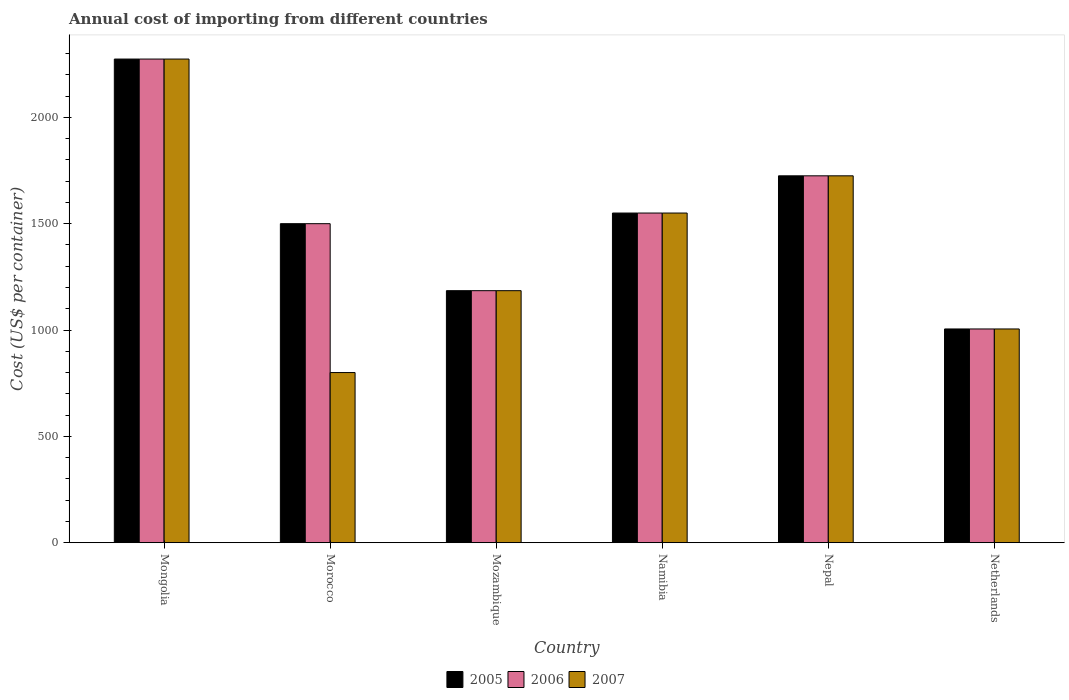How many groups of bars are there?
Offer a very short reply. 6. How many bars are there on the 4th tick from the left?
Offer a very short reply. 3. How many bars are there on the 1st tick from the right?
Your response must be concise. 3. What is the label of the 5th group of bars from the left?
Ensure brevity in your answer.  Nepal. In how many cases, is the number of bars for a given country not equal to the number of legend labels?
Provide a short and direct response. 0. What is the total annual cost of importing in 2007 in Netherlands?
Your answer should be very brief. 1005. Across all countries, what is the maximum total annual cost of importing in 2006?
Provide a succinct answer. 2274. Across all countries, what is the minimum total annual cost of importing in 2006?
Ensure brevity in your answer.  1005. In which country was the total annual cost of importing in 2005 maximum?
Your answer should be very brief. Mongolia. What is the total total annual cost of importing in 2007 in the graph?
Ensure brevity in your answer.  8539. What is the difference between the total annual cost of importing in 2005 in Morocco and that in Mozambique?
Your response must be concise. 315. What is the difference between the total annual cost of importing in 2007 in Morocco and the total annual cost of importing in 2006 in Namibia?
Provide a short and direct response. -750. What is the average total annual cost of importing in 2005 per country?
Provide a succinct answer. 1539.83. What is the ratio of the total annual cost of importing in 2006 in Nepal to that in Netherlands?
Provide a short and direct response. 1.72. Is the total annual cost of importing in 2005 in Mongolia less than that in Namibia?
Offer a very short reply. No. Is the difference between the total annual cost of importing in 2007 in Mongolia and Netherlands greater than the difference between the total annual cost of importing in 2006 in Mongolia and Netherlands?
Your answer should be compact. No. What is the difference between the highest and the second highest total annual cost of importing in 2007?
Offer a terse response. 549. What is the difference between the highest and the lowest total annual cost of importing in 2006?
Make the answer very short. 1269. In how many countries, is the total annual cost of importing in 2005 greater than the average total annual cost of importing in 2005 taken over all countries?
Provide a short and direct response. 3. What does the 1st bar from the left in Mozambique represents?
Your answer should be very brief. 2005. What does the 1st bar from the right in Morocco represents?
Provide a short and direct response. 2007. How many bars are there?
Ensure brevity in your answer.  18. Are all the bars in the graph horizontal?
Provide a short and direct response. No. Does the graph contain any zero values?
Provide a short and direct response. No. Does the graph contain grids?
Offer a very short reply. No. What is the title of the graph?
Make the answer very short. Annual cost of importing from different countries. What is the label or title of the X-axis?
Your response must be concise. Country. What is the label or title of the Y-axis?
Your answer should be very brief. Cost (US$ per container). What is the Cost (US$ per container) of 2005 in Mongolia?
Make the answer very short. 2274. What is the Cost (US$ per container) in 2006 in Mongolia?
Your answer should be compact. 2274. What is the Cost (US$ per container) in 2007 in Mongolia?
Keep it short and to the point. 2274. What is the Cost (US$ per container) of 2005 in Morocco?
Provide a short and direct response. 1500. What is the Cost (US$ per container) of 2006 in Morocco?
Your response must be concise. 1500. What is the Cost (US$ per container) in 2007 in Morocco?
Offer a terse response. 800. What is the Cost (US$ per container) of 2005 in Mozambique?
Offer a very short reply. 1185. What is the Cost (US$ per container) in 2006 in Mozambique?
Make the answer very short. 1185. What is the Cost (US$ per container) of 2007 in Mozambique?
Give a very brief answer. 1185. What is the Cost (US$ per container) in 2005 in Namibia?
Your answer should be very brief. 1550. What is the Cost (US$ per container) of 2006 in Namibia?
Provide a short and direct response. 1550. What is the Cost (US$ per container) in 2007 in Namibia?
Your answer should be compact. 1550. What is the Cost (US$ per container) in 2005 in Nepal?
Your response must be concise. 1725. What is the Cost (US$ per container) in 2006 in Nepal?
Provide a short and direct response. 1725. What is the Cost (US$ per container) of 2007 in Nepal?
Your answer should be compact. 1725. What is the Cost (US$ per container) in 2005 in Netherlands?
Keep it short and to the point. 1005. What is the Cost (US$ per container) in 2006 in Netherlands?
Your response must be concise. 1005. What is the Cost (US$ per container) of 2007 in Netherlands?
Give a very brief answer. 1005. Across all countries, what is the maximum Cost (US$ per container) in 2005?
Offer a terse response. 2274. Across all countries, what is the maximum Cost (US$ per container) of 2006?
Your answer should be very brief. 2274. Across all countries, what is the maximum Cost (US$ per container) of 2007?
Make the answer very short. 2274. Across all countries, what is the minimum Cost (US$ per container) in 2005?
Your answer should be compact. 1005. Across all countries, what is the minimum Cost (US$ per container) of 2006?
Make the answer very short. 1005. Across all countries, what is the minimum Cost (US$ per container) of 2007?
Ensure brevity in your answer.  800. What is the total Cost (US$ per container) in 2005 in the graph?
Your answer should be very brief. 9239. What is the total Cost (US$ per container) in 2006 in the graph?
Make the answer very short. 9239. What is the total Cost (US$ per container) of 2007 in the graph?
Your answer should be very brief. 8539. What is the difference between the Cost (US$ per container) in 2005 in Mongolia and that in Morocco?
Your response must be concise. 774. What is the difference between the Cost (US$ per container) of 2006 in Mongolia and that in Morocco?
Your answer should be very brief. 774. What is the difference between the Cost (US$ per container) of 2007 in Mongolia and that in Morocco?
Provide a succinct answer. 1474. What is the difference between the Cost (US$ per container) of 2005 in Mongolia and that in Mozambique?
Your response must be concise. 1089. What is the difference between the Cost (US$ per container) of 2006 in Mongolia and that in Mozambique?
Make the answer very short. 1089. What is the difference between the Cost (US$ per container) of 2007 in Mongolia and that in Mozambique?
Keep it short and to the point. 1089. What is the difference between the Cost (US$ per container) of 2005 in Mongolia and that in Namibia?
Provide a short and direct response. 724. What is the difference between the Cost (US$ per container) of 2006 in Mongolia and that in Namibia?
Give a very brief answer. 724. What is the difference between the Cost (US$ per container) in 2007 in Mongolia and that in Namibia?
Offer a terse response. 724. What is the difference between the Cost (US$ per container) of 2005 in Mongolia and that in Nepal?
Provide a succinct answer. 549. What is the difference between the Cost (US$ per container) in 2006 in Mongolia and that in Nepal?
Offer a very short reply. 549. What is the difference between the Cost (US$ per container) of 2007 in Mongolia and that in Nepal?
Provide a short and direct response. 549. What is the difference between the Cost (US$ per container) of 2005 in Mongolia and that in Netherlands?
Provide a succinct answer. 1269. What is the difference between the Cost (US$ per container) in 2006 in Mongolia and that in Netherlands?
Your response must be concise. 1269. What is the difference between the Cost (US$ per container) of 2007 in Mongolia and that in Netherlands?
Offer a very short reply. 1269. What is the difference between the Cost (US$ per container) of 2005 in Morocco and that in Mozambique?
Your answer should be very brief. 315. What is the difference between the Cost (US$ per container) of 2006 in Morocco and that in Mozambique?
Keep it short and to the point. 315. What is the difference between the Cost (US$ per container) of 2007 in Morocco and that in Mozambique?
Your answer should be compact. -385. What is the difference between the Cost (US$ per container) in 2007 in Morocco and that in Namibia?
Provide a short and direct response. -750. What is the difference between the Cost (US$ per container) in 2005 in Morocco and that in Nepal?
Make the answer very short. -225. What is the difference between the Cost (US$ per container) of 2006 in Morocco and that in Nepal?
Provide a succinct answer. -225. What is the difference between the Cost (US$ per container) in 2007 in Morocco and that in Nepal?
Provide a short and direct response. -925. What is the difference between the Cost (US$ per container) in 2005 in Morocco and that in Netherlands?
Your answer should be very brief. 495. What is the difference between the Cost (US$ per container) of 2006 in Morocco and that in Netherlands?
Your answer should be compact. 495. What is the difference between the Cost (US$ per container) in 2007 in Morocco and that in Netherlands?
Your response must be concise. -205. What is the difference between the Cost (US$ per container) of 2005 in Mozambique and that in Namibia?
Provide a short and direct response. -365. What is the difference between the Cost (US$ per container) of 2006 in Mozambique and that in Namibia?
Give a very brief answer. -365. What is the difference between the Cost (US$ per container) of 2007 in Mozambique and that in Namibia?
Offer a very short reply. -365. What is the difference between the Cost (US$ per container) of 2005 in Mozambique and that in Nepal?
Provide a short and direct response. -540. What is the difference between the Cost (US$ per container) in 2006 in Mozambique and that in Nepal?
Ensure brevity in your answer.  -540. What is the difference between the Cost (US$ per container) in 2007 in Mozambique and that in Nepal?
Offer a terse response. -540. What is the difference between the Cost (US$ per container) in 2005 in Mozambique and that in Netherlands?
Your response must be concise. 180. What is the difference between the Cost (US$ per container) of 2006 in Mozambique and that in Netherlands?
Give a very brief answer. 180. What is the difference between the Cost (US$ per container) in 2007 in Mozambique and that in Netherlands?
Provide a short and direct response. 180. What is the difference between the Cost (US$ per container) of 2005 in Namibia and that in Nepal?
Ensure brevity in your answer.  -175. What is the difference between the Cost (US$ per container) of 2006 in Namibia and that in Nepal?
Ensure brevity in your answer.  -175. What is the difference between the Cost (US$ per container) of 2007 in Namibia and that in Nepal?
Your response must be concise. -175. What is the difference between the Cost (US$ per container) in 2005 in Namibia and that in Netherlands?
Make the answer very short. 545. What is the difference between the Cost (US$ per container) of 2006 in Namibia and that in Netherlands?
Your answer should be compact. 545. What is the difference between the Cost (US$ per container) in 2007 in Namibia and that in Netherlands?
Make the answer very short. 545. What is the difference between the Cost (US$ per container) in 2005 in Nepal and that in Netherlands?
Keep it short and to the point. 720. What is the difference between the Cost (US$ per container) in 2006 in Nepal and that in Netherlands?
Provide a succinct answer. 720. What is the difference between the Cost (US$ per container) in 2007 in Nepal and that in Netherlands?
Your answer should be very brief. 720. What is the difference between the Cost (US$ per container) in 2005 in Mongolia and the Cost (US$ per container) in 2006 in Morocco?
Offer a very short reply. 774. What is the difference between the Cost (US$ per container) in 2005 in Mongolia and the Cost (US$ per container) in 2007 in Morocco?
Offer a terse response. 1474. What is the difference between the Cost (US$ per container) of 2006 in Mongolia and the Cost (US$ per container) of 2007 in Morocco?
Make the answer very short. 1474. What is the difference between the Cost (US$ per container) in 2005 in Mongolia and the Cost (US$ per container) in 2006 in Mozambique?
Provide a short and direct response. 1089. What is the difference between the Cost (US$ per container) of 2005 in Mongolia and the Cost (US$ per container) of 2007 in Mozambique?
Ensure brevity in your answer.  1089. What is the difference between the Cost (US$ per container) of 2006 in Mongolia and the Cost (US$ per container) of 2007 in Mozambique?
Make the answer very short. 1089. What is the difference between the Cost (US$ per container) in 2005 in Mongolia and the Cost (US$ per container) in 2006 in Namibia?
Offer a very short reply. 724. What is the difference between the Cost (US$ per container) in 2005 in Mongolia and the Cost (US$ per container) in 2007 in Namibia?
Your answer should be very brief. 724. What is the difference between the Cost (US$ per container) of 2006 in Mongolia and the Cost (US$ per container) of 2007 in Namibia?
Keep it short and to the point. 724. What is the difference between the Cost (US$ per container) of 2005 in Mongolia and the Cost (US$ per container) of 2006 in Nepal?
Your response must be concise. 549. What is the difference between the Cost (US$ per container) of 2005 in Mongolia and the Cost (US$ per container) of 2007 in Nepal?
Ensure brevity in your answer.  549. What is the difference between the Cost (US$ per container) of 2006 in Mongolia and the Cost (US$ per container) of 2007 in Nepal?
Your answer should be very brief. 549. What is the difference between the Cost (US$ per container) in 2005 in Mongolia and the Cost (US$ per container) in 2006 in Netherlands?
Make the answer very short. 1269. What is the difference between the Cost (US$ per container) in 2005 in Mongolia and the Cost (US$ per container) in 2007 in Netherlands?
Your answer should be very brief. 1269. What is the difference between the Cost (US$ per container) of 2006 in Mongolia and the Cost (US$ per container) of 2007 in Netherlands?
Your response must be concise. 1269. What is the difference between the Cost (US$ per container) of 2005 in Morocco and the Cost (US$ per container) of 2006 in Mozambique?
Your response must be concise. 315. What is the difference between the Cost (US$ per container) of 2005 in Morocco and the Cost (US$ per container) of 2007 in Mozambique?
Keep it short and to the point. 315. What is the difference between the Cost (US$ per container) of 2006 in Morocco and the Cost (US$ per container) of 2007 in Mozambique?
Offer a terse response. 315. What is the difference between the Cost (US$ per container) in 2005 in Morocco and the Cost (US$ per container) in 2006 in Namibia?
Keep it short and to the point. -50. What is the difference between the Cost (US$ per container) of 2005 in Morocco and the Cost (US$ per container) of 2006 in Nepal?
Keep it short and to the point. -225. What is the difference between the Cost (US$ per container) in 2005 in Morocco and the Cost (US$ per container) in 2007 in Nepal?
Give a very brief answer. -225. What is the difference between the Cost (US$ per container) in 2006 in Morocco and the Cost (US$ per container) in 2007 in Nepal?
Your answer should be very brief. -225. What is the difference between the Cost (US$ per container) of 2005 in Morocco and the Cost (US$ per container) of 2006 in Netherlands?
Provide a short and direct response. 495. What is the difference between the Cost (US$ per container) in 2005 in Morocco and the Cost (US$ per container) in 2007 in Netherlands?
Provide a short and direct response. 495. What is the difference between the Cost (US$ per container) in 2006 in Morocco and the Cost (US$ per container) in 2007 in Netherlands?
Offer a very short reply. 495. What is the difference between the Cost (US$ per container) in 2005 in Mozambique and the Cost (US$ per container) in 2006 in Namibia?
Make the answer very short. -365. What is the difference between the Cost (US$ per container) of 2005 in Mozambique and the Cost (US$ per container) of 2007 in Namibia?
Ensure brevity in your answer.  -365. What is the difference between the Cost (US$ per container) in 2006 in Mozambique and the Cost (US$ per container) in 2007 in Namibia?
Keep it short and to the point. -365. What is the difference between the Cost (US$ per container) in 2005 in Mozambique and the Cost (US$ per container) in 2006 in Nepal?
Provide a short and direct response. -540. What is the difference between the Cost (US$ per container) in 2005 in Mozambique and the Cost (US$ per container) in 2007 in Nepal?
Offer a terse response. -540. What is the difference between the Cost (US$ per container) in 2006 in Mozambique and the Cost (US$ per container) in 2007 in Nepal?
Your response must be concise. -540. What is the difference between the Cost (US$ per container) of 2005 in Mozambique and the Cost (US$ per container) of 2006 in Netherlands?
Ensure brevity in your answer.  180. What is the difference between the Cost (US$ per container) of 2005 in Mozambique and the Cost (US$ per container) of 2007 in Netherlands?
Give a very brief answer. 180. What is the difference between the Cost (US$ per container) in 2006 in Mozambique and the Cost (US$ per container) in 2007 in Netherlands?
Your answer should be compact. 180. What is the difference between the Cost (US$ per container) in 2005 in Namibia and the Cost (US$ per container) in 2006 in Nepal?
Keep it short and to the point. -175. What is the difference between the Cost (US$ per container) in 2005 in Namibia and the Cost (US$ per container) in 2007 in Nepal?
Your answer should be compact. -175. What is the difference between the Cost (US$ per container) of 2006 in Namibia and the Cost (US$ per container) of 2007 in Nepal?
Offer a very short reply. -175. What is the difference between the Cost (US$ per container) in 2005 in Namibia and the Cost (US$ per container) in 2006 in Netherlands?
Offer a terse response. 545. What is the difference between the Cost (US$ per container) in 2005 in Namibia and the Cost (US$ per container) in 2007 in Netherlands?
Ensure brevity in your answer.  545. What is the difference between the Cost (US$ per container) of 2006 in Namibia and the Cost (US$ per container) of 2007 in Netherlands?
Your answer should be very brief. 545. What is the difference between the Cost (US$ per container) in 2005 in Nepal and the Cost (US$ per container) in 2006 in Netherlands?
Make the answer very short. 720. What is the difference between the Cost (US$ per container) in 2005 in Nepal and the Cost (US$ per container) in 2007 in Netherlands?
Your answer should be very brief. 720. What is the difference between the Cost (US$ per container) of 2006 in Nepal and the Cost (US$ per container) of 2007 in Netherlands?
Ensure brevity in your answer.  720. What is the average Cost (US$ per container) of 2005 per country?
Provide a succinct answer. 1539.83. What is the average Cost (US$ per container) in 2006 per country?
Your answer should be compact. 1539.83. What is the average Cost (US$ per container) in 2007 per country?
Ensure brevity in your answer.  1423.17. What is the difference between the Cost (US$ per container) of 2005 and Cost (US$ per container) of 2006 in Mongolia?
Provide a short and direct response. 0. What is the difference between the Cost (US$ per container) in 2005 and Cost (US$ per container) in 2007 in Mongolia?
Ensure brevity in your answer.  0. What is the difference between the Cost (US$ per container) in 2005 and Cost (US$ per container) in 2007 in Morocco?
Ensure brevity in your answer.  700. What is the difference between the Cost (US$ per container) of 2006 and Cost (US$ per container) of 2007 in Morocco?
Give a very brief answer. 700. What is the difference between the Cost (US$ per container) of 2005 and Cost (US$ per container) of 2006 in Mozambique?
Offer a very short reply. 0. What is the difference between the Cost (US$ per container) of 2005 and Cost (US$ per container) of 2007 in Mozambique?
Make the answer very short. 0. What is the difference between the Cost (US$ per container) of 2005 and Cost (US$ per container) of 2006 in Nepal?
Provide a succinct answer. 0. What is the difference between the Cost (US$ per container) of 2005 and Cost (US$ per container) of 2007 in Nepal?
Your answer should be compact. 0. What is the difference between the Cost (US$ per container) of 2006 and Cost (US$ per container) of 2007 in Nepal?
Your answer should be very brief. 0. What is the difference between the Cost (US$ per container) in 2005 and Cost (US$ per container) in 2006 in Netherlands?
Give a very brief answer. 0. What is the difference between the Cost (US$ per container) in 2005 and Cost (US$ per container) in 2007 in Netherlands?
Your answer should be compact. 0. What is the difference between the Cost (US$ per container) of 2006 and Cost (US$ per container) of 2007 in Netherlands?
Keep it short and to the point. 0. What is the ratio of the Cost (US$ per container) of 2005 in Mongolia to that in Morocco?
Offer a very short reply. 1.52. What is the ratio of the Cost (US$ per container) of 2006 in Mongolia to that in Morocco?
Provide a succinct answer. 1.52. What is the ratio of the Cost (US$ per container) in 2007 in Mongolia to that in Morocco?
Make the answer very short. 2.84. What is the ratio of the Cost (US$ per container) of 2005 in Mongolia to that in Mozambique?
Provide a succinct answer. 1.92. What is the ratio of the Cost (US$ per container) of 2006 in Mongolia to that in Mozambique?
Your response must be concise. 1.92. What is the ratio of the Cost (US$ per container) in 2007 in Mongolia to that in Mozambique?
Offer a very short reply. 1.92. What is the ratio of the Cost (US$ per container) of 2005 in Mongolia to that in Namibia?
Offer a terse response. 1.47. What is the ratio of the Cost (US$ per container) in 2006 in Mongolia to that in Namibia?
Keep it short and to the point. 1.47. What is the ratio of the Cost (US$ per container) in 2007 in Mongolia to that in Namibia?
Make the answer very short. 1.47. What is the ratio of the Cost (US$ per container) in 2005 in Mongolia to that in Nepal?
Your answer should be very brief. 1.32. What is the ratio of the Cost (US$ per container) of 2006 in Mongolia to that in Nepal?
Ensure brevity in your answer.  1.32. What is the ratio of the Cost (US$ per container) of 2007 in Mongolia to that in Nepal?
Ensure brevity in your answer.  1.32. What is the ratio of the Cost (US$ per container) in 2005 in Mongolia to that in Netherlands?
Provide a short and direct response. 2.26. What is the ratio of the Cost (US$ per container) of 2006 in Mongolia to that in Netherlands?
Your answer should be compact. 2.26. What is the ratio of the Cost (US$ per container) of 2007 in Mongolia to that in Netherlands?
Your answer should be very brief. 2.26. What is the ratio of the Cost (US$ per container) in 2005 in Morocco to that in Mozambique?
Offer a very short reply. 1.27. What is the ratio of the Cost (US$ per container) in 2006 in Morocco to that in Mozambique?
Make the answer very short. 1.27. What is the ratio of the Cost (US$ per container) of 2007 in Morocco to that in Mozambique?
Provide a succinct answer. 0.68. What is the ratio of the Cost (US$ per container) in 2005 in Morocco to that in Namibia?
Your answer should be very brief. 0.97. What is the ratio of the Cost (US$ per container) of 2007 in Morocco to that in Namibia?
Provide a short and direct response. 0.52. What is the ratio of the Cost (US$ per container) in 2005 in Morocco to that in Nepal?
Provide a short and direct response. 0.87. What is the ratio of the Cost (US$ per container) of 2006 in Morocco to that in Nepal?
Ensure brevity in your answer.  0.87. What is the ratio of the Cost (US$ per container) of 2007 in Morocco to that in Nepal?
Give a very brief answer. 0.46. What is the ratio of the Cost (US$ per container) in 2005 in Morocco to that in Netherlands?
Ensure brevity in your answer.  1.49. What is the ratio of the Cost (US$ per container) of 2006 in Morocco to that in Netherlands?
Provide a short and direct response. 1.49. What is the ratio of the Cost (US$ per container) in 2007 in Morocco to that in Netherlands?
Your answer should be very brief. 0.8. What is the ratio of the Cost (US$ per container) in 2005 in Mozambique to that in Namibia?
Give a very brief answer. 0.76. What is the ratio of the Cost (US$ per container) of 2006 in Mozambique to that in Namibia?
Provide a short and direct response. 0.76. What is the ratio of the Cost (US$ per container) in 2007 in Mozambique to that in Namibia?
Give a very brief answer. 0.76. What is the ratio of the Cost (US$ per container) of 2005 in Mozambique to that in Nepal?
Make the answer very short. 0.69. What is the ratio of the Cost (US$ per container) in 2006 in Mozambique to that in Nepal?
Offer a terse response. 0.69. What is the ratio of the Cost (US$ per container) of 2007 in Mozambique to that in Nepal?
Offer a terse response. 0.69. What is the ratio of the Cost (US$ per container) of 2005 in Mozambique to that in Netherlands?
Offer a very short reply. 1.18. What is the ratio of the Cost (US$ per container) in 2006 in Mozambique to that in Netherlands?
Provide a short and direct response. 1.18. What is the ratio of the Cost (US$ per container) of 2007 in Mozambique to that in Netherlands?
Provide a short and direct response. 1.18. What is the ratio of the Cost (US$ per container) in 2005 in Namibia to that in Nepal?
Your answer should be compact. 0.9. What is the ratio of the Cost (US$ per container) of 2006 in Namibia to that in Nepal?
Provide a succinct answer. 0.9. What is the ratio of the Cost (US$ per container) in 2007 in Namibia to that in Nepal?
Your answer should be compact. 0.9. What is the ratio of the Cost (US$ per container) of 2005 in Namibia to that in Netherlands?
Your answer should be very brief. 1.54. What is the ratio of the Cost (US$ per container) in 2006 in Namibia to that in Netherlands?
Provide a short and direct response. 1.54. What is the ratio of the Cost (US$ per container) of 2007 in Namibia to that in Netherlands?
Offer a very short reply. 1.54. What is the ratio of the Cost (US$ per container) of 2005 in Nepal to that in Netherlands?
Provide a short and direct response. 1.72. What is the ratio of the Cost (US$ per container) of 2006 in Nepal to that in Netherlands?
Keep it short and to the point. 1.72. What is the ratio of the Cost (US$ per container) of 2007 in Nepal to that in Netherlands?
Give a very brief answer. 1.72. What is the difference between the highest and the second highest Cost (US$ per container) in 2005?
Your response must be concise. 549. What is the difference between the highest and the second highest Cost (US$ per container) in 2006?
Provide a short and direct response. 549. What is the difference between the highest and the second highest Cost (US$ per container) in 2007?
Your answer should be compact. 549. What is the difference between the highest and the lowest Cost (US$ per container) in 2005?
Provide a succinct answer. 1269. What is the difference between the highest and the lowest Cost (US$ per container) in 2006?
Make the answer very short. 1269. What is the difference between the highest and the lowest Cost (US$ per container) in 2007?
Your response must be concise. 1474. 